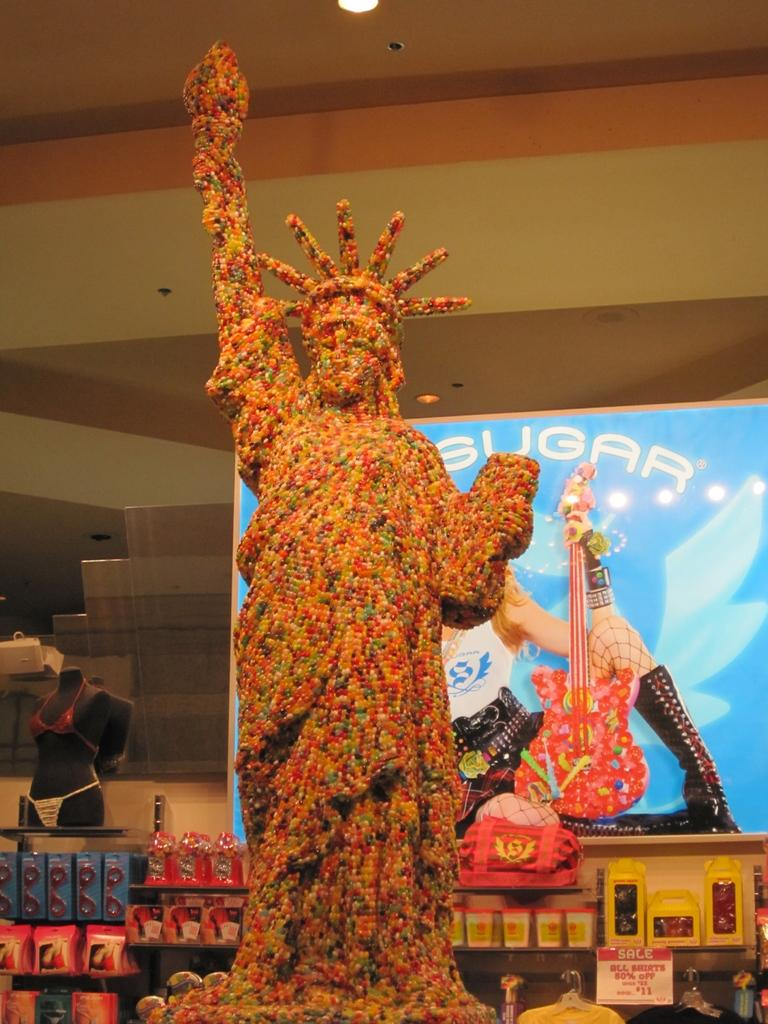What is the main subject of the image? The main subject of the image is a statue of liberty made up of candies. What else can be seen in the image besides the statue? There are boards and a mannequin visible in the image. Are there any objects in the background of the image? Yes, there are objects visible in the background of the image. What type of soda is being poured into the mannequin's mouth in the image? There is no soda or pouring action present in the image. Can you hear the whistle of the mannequin in the image? There is no whistle or sound associated with the mannequin in the image. 